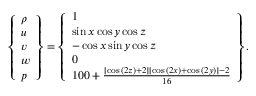Convert formula to latex. <formula><loc_0><loc_0><loc_500><loc_500>\left \{ \begin{array} { l } { \rho } \\ { u } \\ { v } \\ { w } \\ { p } \end{array} \right \} = \left \{ \begin{array} { l } { 1 } \\ { \sin { x } \cos { y } \cos { z } } \\ { - \cos { x } \sin { y } \cos { z } } \\ { 0 } \\ { 1 0 0 + \frac { \left [ \cos { ( 2 z ) } + 2 \right ] \left [ \cos { ( 2 x ) } + \cos { ( 2 y ) } \right ] - 2 } { 1 6 } } \end{array} \right \} .</formula> 